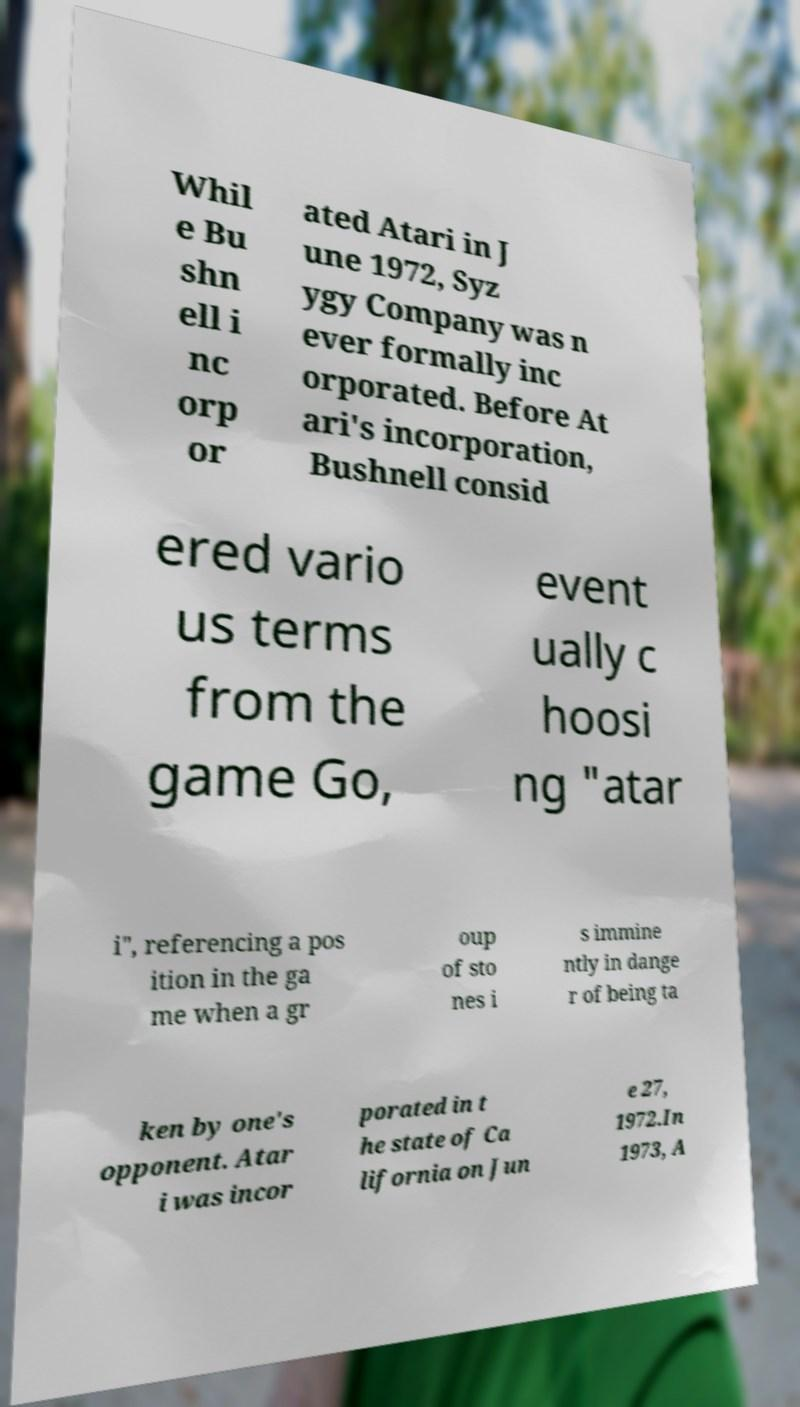Can you accurately transcribe the text from the provided image for me? Whil e Bu shn ell i nc orp or ated Atari in J une 1972, Syz ygy Company was n ever formally inc orporated. Before At ari's incorporation, Bushnell consid ered vario us terms from the game Go, event ually c hoosi ng "atar i", referencing a pos ition in the ga me when a gr oup of sto nes i s immine ntly in dange r of being ta ken by one's opponent. Atar i was incor porated in t he state of Ca lifornia on Jun e 27, 1972.In 1973, A 